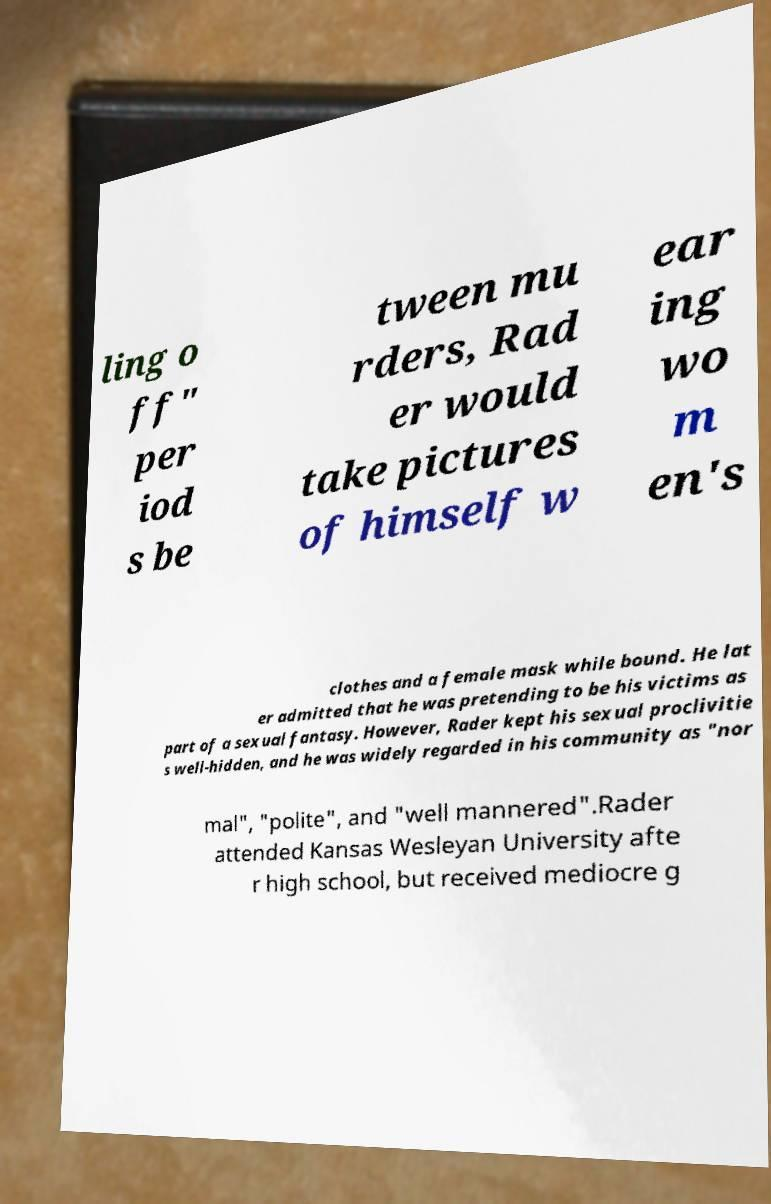Could you extract and type out the text from this image? ling o ff" per iod s be tween mu rders, Rad er would take pictures of himself w ear ing wo m en's clothes and a female mask while bound. He lat er admitted that he was pretending to be his victims as part of a sexual fantasy. However, Rader kept his sexual proclivitie s well-hidden, and he was widely regarded in his community as "nor mal", "polite", and "well mannered".Rader attended Kansas Wesleyan University afte r high school, but received mediocre g 